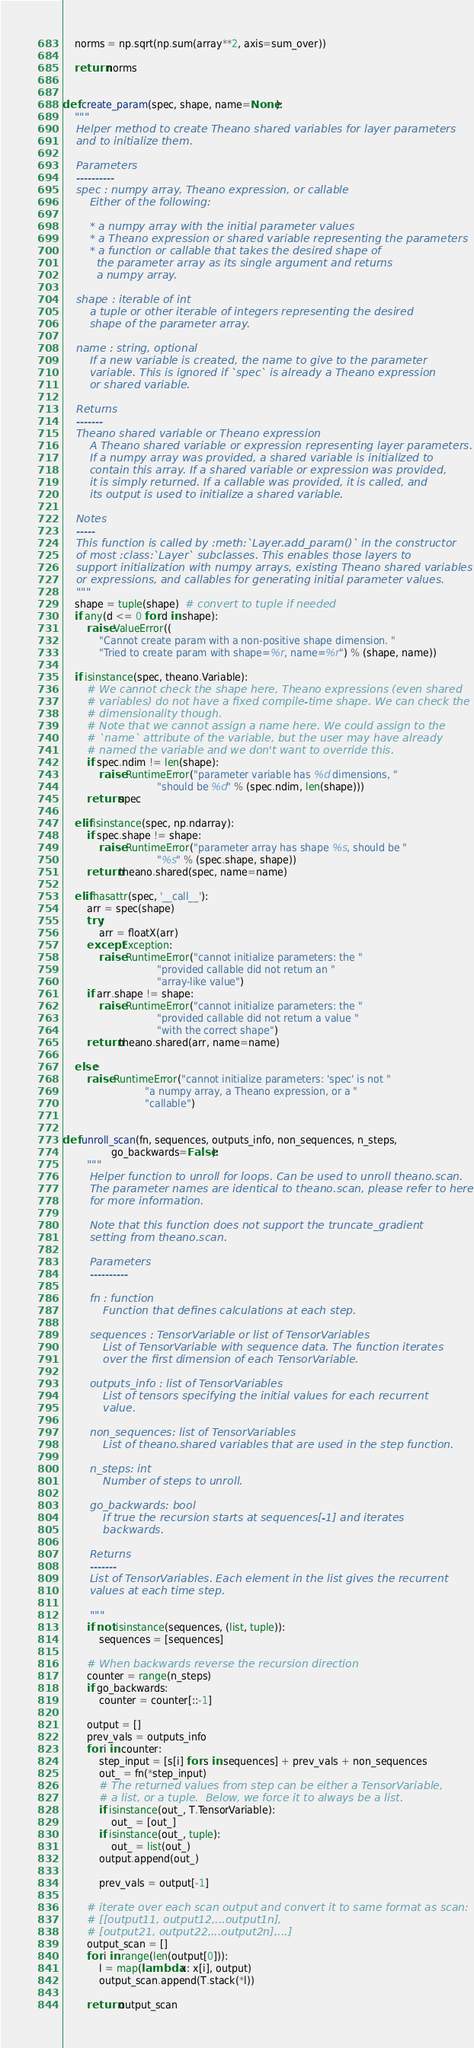Convert code to text. <code><loc_0><loc_0><loc_500><loc_500><_Python_>
    norms = np.sqrt(np.sum(array**2, axis=sum_over))

    return norms


def create_param(spec, shape, name=None):
    """
    Helper method to create Theano shared variables for layer parameters
    and to initialize them.

    Parameters
    ----------
    spec : numpy array, Theano expression, or callable
        Either of the following:

        * a numpy array with the initial parameter values
        * a Theano expression or shared variable representing the parameters
        * a function or callable that takes the desired shape of
          the parameter array as its single argument and returns
          a numpy array.

    shape : iterable of int
        a tuple or other iterable of integers representing the desired
        shape of the parameter array.

    name : string, optional
        If a new variable is created, the name to give to the parameter
        variable. This is ignored if `spec` is already a Theano expression
        or shared variable.

    Returns
    -------
    Theano shared variable or Theano expression
        A Theano shared variable or expression representing layer parameters.
        If a numpy array was provided, a shared variable is initialized to
        contain this array. If a shared variable or expression was provided,
        it is simply returned. If a callable was provided, it is called, and
        its output is used to initialize a shared variable.

    Notes
    -----
    This function is called by :meth:`Layer.add_param()` in the constructor
    of most :class:`Layer` subclasses. This enables those layers to
    support initialization with numpy arrays, existing Theano shared variables
    or expressions, and callables for generating initial parameter values.
    """
    shape = tuple(shape)  # convert to tuple if needed
    if any(d <= 0 for d in shape):
        raise ValueError((
            "Cannot create param with a non-positive shape dimension. "
            "Tried to create param with shape=%r, name=%r") % (shape, name))

    if isinstance(spec, theano.Variable):
        # We cannot check the shape here, Theano expressions (even shared
        # variables) do not have a fixed compile-time shape. We can check the
        # dimensionality though.
        # Note that we cannot assign a name here. We could assign to the
        # `name` attribute of the variable, but the user may have already
        # named the variable and we don't want to override this.
        if spec.ndim != len(shape):
            raise RuntimeError("parameter variable has %d dimensions, "
                               "should be %d" % (spec.ndim, len(shape)))
        return spec

    elif isinstance(spec, np.ndarray):
        if spec.shape != shape:
            raise RuntimeError("parameter array has shape %s, should be "
                               "%s" % (spec.shape, shape))
        return theano.shared(spec, name=name)

    elif hasattr(spec, '__call__'):
        arr = spec(shape)
        try:
            arr = floatX(arr)
        except Exception:
            raise RuntimeError("cannot initialize parameters: the "
                               "provided callable did not return an "
                               "array-like value")
        if arr.shape != shape:
            raise RuntimeError("cannot initialize parameters: the "
                               "provided callable did not return a value "
                               "with the correct shape")
        return theano.shared(arr, name=name)

    else:
        raise RuntimeError("cannot initialize parameters: 'spec' is not "
                           "a numpy array, a Theano expression, or a "
                           "callable")


def unroll_scan(fn, sequences, outputs_info, non_sequences, n_steps,
                go_backwards=False):
        """
        Helper function to unroll for loops. Can be used to unroll theano.scan.
        The parameter names are identical to theano.scan, please refer to here
        for more information.

        Note that this function does not support the truncate_gradient
        setting from theano.scan.

        Parameters
        ----------

        fn : function
            Function that defines calculations at each step.

        sequences : TensorVariable or list of TensorVariables
            List of TensorVariable with sequence data. The function iterates
            over the first dimension of each TensorVariable.

        outputs_info : list of TensorVariables
            List of tensors specifying the initial values for each recurrent
            value.

        non_sequences: list of TensorVariables
            List of theano.shared variables that are used in the step function.

        n_steps: int
            Number of steps to unroll.

        go_backwards: bool
            If true the recursion starts at sequences[-1] and iterates
            backwards.

        Returns
        -------
        List of TensorVariables. Each element in the list gives the recurrent
        values at each time step.

        """
        if not isinstance(sequences, (list, tuple)):
            sequences = [sequences]

        # When backwards reverse the recursion direction
        counter = range(n_steps)
        if go_backwards:
            counter = counter[::-1]

        output = []
        prev_vals = outputs_info
        for i in counter:
            step_input = [s[i] for s in sequences] + prev_vals + non_sequences
            out_ = fn(*step_input)
            # The returned values from step can be either a TensorVariable,
            # a list, or a tuple.  Below, we force it to always be a list.
            if isinstance(out_, T.TensorVariable):
                out_ = [out_]
            if isinstance(out_, tuple):
                out_ = list(out_)
            output.append(out_)

            prev_vals = output[-1]

        # iterate over each scan output and convert it to same format as scan:
        # [[output11, output12,...output1n],
        # [output21, output22,...output2n],...]
        output_scan = []
        for i in range(len(output[0])):
            l = map(lambda x: x[i], output)
            output_scan.append(T.stack(*l))

        return output_scan
</code> 